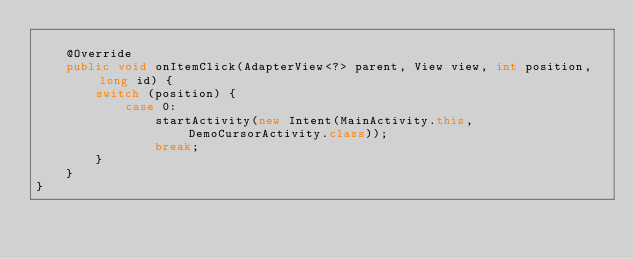Convert code to text. <code><loc_0><loc_0><loc_500><loc_500><_Java_>
    @Override
    public void onItemClick(AdapterView<?> parent, View view, int position, long id) {
        switch (position) {
            case 0:
                startActivity(new Intent(MainActivity.this, DemoCursorActivity.class));
                break;
        }
    }
}
</code> 